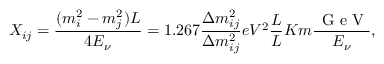Convert formula to latex. <formula><loc_0><loc_0><loc_500><loc_500>X _ { i j } = \frac { ( m _ { i } ^ { 2 } - m _ { j } ^ { 2 } ) L } { 4 E _ { \nu } } = 1 . 2 6 7 \frac { \Delta m _ { i j } ^ { 2 } } { \Delta m _ { i j } ^ { 2 } } { e V ^ { 2 } } \frac { L } { L } { K m } \frac { \, G e V } { E _ { \nu } } ,</formula> 